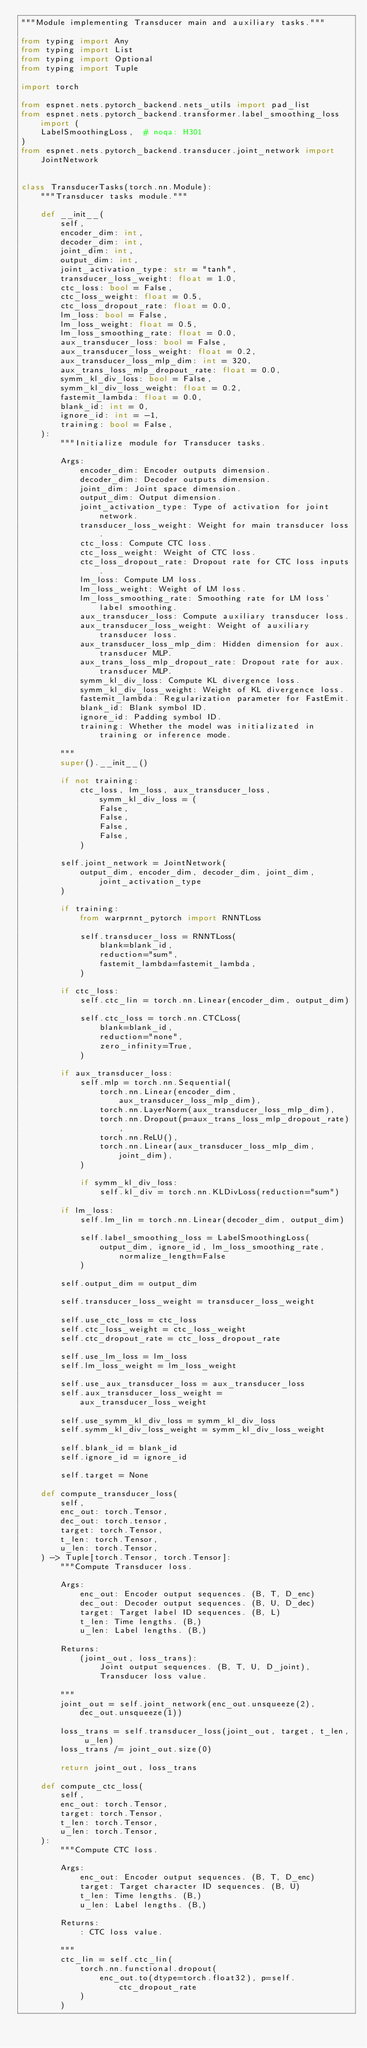<code> <loc_0><loc_0><loc_500><loc_500><_Python_>"""Module implementing Transducer main and auxiliary tasks."""

from typing import Any
from typing import List
from typing import Optional
from typing import Tuple

import torch

from espnet.nets.pytorch_backend.nets_utils import pad_list
from espnet.nets.pytorch_backend.transformer.label_smoothing_loss import (
    LabelSmoothingLoss,  # noqa: H301
)
from espnet.nets.pytorch_backend.transducer.joint_network import JointNetwork


class TransducerTasks(torch.nn.Module):
    """Transducer tasks module."""

    def __init__(
        self,
        encoder_dim: int,
        decoder_dim: int,
        joint_dim: int,
        output_dim: int,
        joint_activation_type: str = "tanh",
        transducer_loss_weight: float = 1.0,
        ctc_loss: bool = False,
        ctc_loss_weight: float = 0.5,
        ctc_loss_dropout_rate: float = 0.0,
        lm_loss: bool = False,
        lm_loss_weight: float = 0.5,
        lm_loss_smoothing_rate: float = 0.0,
        aux_transducer_loss: bool = False,
        aux_transducer_loss_weight: float = 0.2,
        aux_transducer_loss_mlp_dim: int = 320,
        aux_trans_loss_mlp_dropout_rate: float = 0.0,
        symm_kl_div_loss: bool = False,
        symm_kl_div_loss_weight: float = 0.2,
        fastemit_lambda: float = 0.0,
        blank_id: int = 0,
        ignore_id: int = -1,
        training: bool = False,
    ):
        """Initialize module for Transducer tasks.

        Args:
            encoder_dim: Encoder outputs dimension.
            decoder_dim: Decoder outputs dimension.
            joint_dim: Joint space dimension.
            output_dim: Output dimension.
            joint_activation_type: Type of activation for joint network.
            transducer_loss_weight: Weight for main transducer loss.
            ctc_loss: Compute CTC loss.
            ctc_loss_weight: Weight of CTC loss.
            ctc_loss_dropout_rate: Dropout rate for CTC loss inputs.
            lm_loss: Compute LM loss.
            lm_loss_weight: Weight of LM loss.
            lm_loss_smoothing_rate: Smoothing rate for LM loss' label smoothing.
            aux_transducer_loss: Compute auxiliary transducer loss.
            aux_transducer_loss_weight: Weight of auxiliary transducer loss.
            aux_transducer_loss_mlp_dim: Hidden dimension for aux. transducer MLP.
            aux_trans_loss_mlp_dropout_rate: Dropout rate for aux. transducer MLP.
            symm_kl_div_loss: Compute KL divergence loss.
            symm_kl_div_loss_weight: Weight of KL divergence loss.
            fastemit_lambda: Regularization parameter for FastEmit.
            blank_id: Blank symbol ID.
            ignore_id: Padding symbol ID.
            training: Whether the model was initializated in training or inference mode.

        """
        super().__init__()

        if not training:
            ctc_loss, lm_loss, aux_transducer_loss, symm_kl_div_loss = (
                False,
                False,
                False,
                False,
            )

        self.joint_network = JointNetwork(
            output_dim, encoder_dim, decoder_dim, joint_dim, joint_activation_type
        )

        if training:
            from warprnnt_pytorch import RNNTLoss

            self.transducer_loss = RNNTLoss(
                blank=blank_id,
                reduction="sum",
                fastemit_lambda=fastemit_lambda,
            )

        if ctc_loss:
            self.ctc_lin = torch.nn.Linear(encoder_dim, output_dim)

            self.ctc_loss = torch.nn.CTCLoss(
                blank=blank_id,
                reduction="none",
                zero_infinity=True,
            )

        if aux_transducer_loss:
            self.mlp = torch.nn.Sequential(
                torch.nn.Linear(encoder_dim, aux_transducer_loss_mlp_dim),
                torch.nn.LayerNorm(aux_transducer_loss_mlp_dim),
                torch.nn.Dropout(p=aux_trans_loss_mlp_dropout_rate),
                torch.nn.ReLU(),
                torch.nn.Linear(aux_transducer_loss_mlp_dim, joint_dim),
            )

            if symm_kl_div_loss:
                self.kl_div = torch.nn.KLDivLoss(reduction="sum")

        if lm_loss:
            self.lm_lin = torch.nn.Linear(decoder_dim, output_dim)

            self.label_smoothing_loss = LabelSmoothingLoss(
                output_dim, ignore_id, lm_loss_smoothing_rate, normalize_length=False
            )

        self.output_dim = output_dim

        self.transducer_loss_weight = transducer_loss_weight

        self.use_ctc_loss = ctc_loss
        self.ctc_loss_weight = ctc_loss_weight
        self.ctc_dropout_rate = ctc_loss_dropout_rate

        self.use_lm_loss = lm_loss
        self.lm_loss_weight = lm_loss_weight

        self.use_aux_transducer_loss = aux_transducer_loss
        self.aux_transducer_loss_weight = aux_transducer_loss_weight

        self.use_symm_kl_div_loss = symm_kl_div_loss
        self.symm_kl_div_loss_weight = symm_kl_div_loss_weight

        self.blank_id = blank_id
        self.ignore_id = ignore_id

        self.target = None

    def compute_transducer_loss(
        self,
        enc_out: torch.Tensor,
        dec_out: torch.tensor,
        target: torch.Tensor,
        t_len: torch.Tensor,
        u_len: torch.Tensor,
    ) -> Tuple[torch.Tensor, torch.Tensor]:
        """Compute Transducer loss.

        Args:
            enc_out: Encoder output sequences. (B, T, D_enc)
            dec_out: Decoder output sequences. (B, U, D_dec)
            target: Target label ID sequences. (B, L)
            t_len: Time lengths. (B,)
            u_len: Label lengths. (B,)

        Returns:
            (joint_out, loss_trans):
                Joint output sequences. (B, T, U, D_joint),
                Transducer loss value.

        """
        joint_out = self.joint_network(enc_out.unsqueeze(2), dec_out.unsqueeze(1))

        loss_trans = self.transducer_loss(joint_out, target, t_len, u_len)
        loss_trans /= joint_out.size(0)

        return joint_out, loss_trans

    def compute_ctc_loss(
        self,
        enc_out: torch.Tensor,
        target: torch.Tensor,
        t_len: torch.Tensor,
        u_len: torch.Tensor,
    ):
        """Compute CTC loss.

        Args:
            enc_out: Encoder output sequences. (B, T, D_enc)
            target: Target character ID sequences. (B, U)
            t_len: Time lengths. (B,)
            u_len: Label lengths. (B,)

        Returns:
            : CTC loss value.

        """
        ctc_lin = self.ctc_lin(
            torch.nn.functional.dropout(
                enc_out.to(dtype=torch.float32), p=self.ctc_dropout_rate
            )
        )</code> 